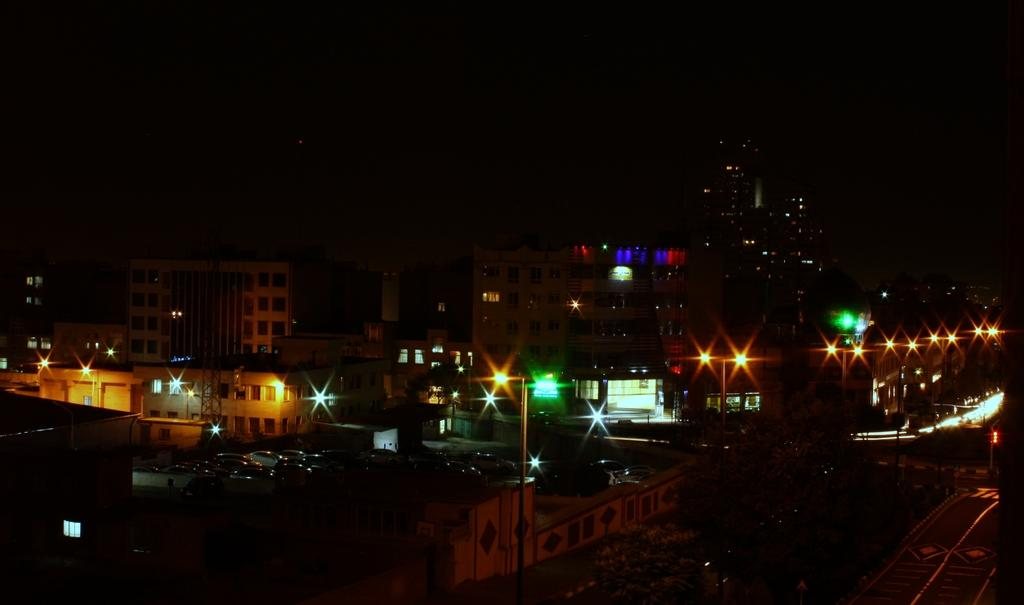What type of structures can be seen in the image? There are buildings in the image. What else is present in the image besides the buildings? There are light poles in the image. What is the color of the background in the image? The background of the image is dark. What is visible in the sky in the image? The sky is visible in the image. Reasoning: Let' Let's think step by step in order to produce the conversation. We start by identifying the main subjects in the image, which are the buildings. Then, we expand the conversation to include other items that are also visible, such as light poles. We also describe the background and the sky, which provide context for the image. Absurd Question/Answer: Can you see any toes on the buildings in the image? There are no toes present in the image, as it features buildings and light poles. What type of liquid is being poured from the desk in the image? There is no desk or liquid present in the image. 